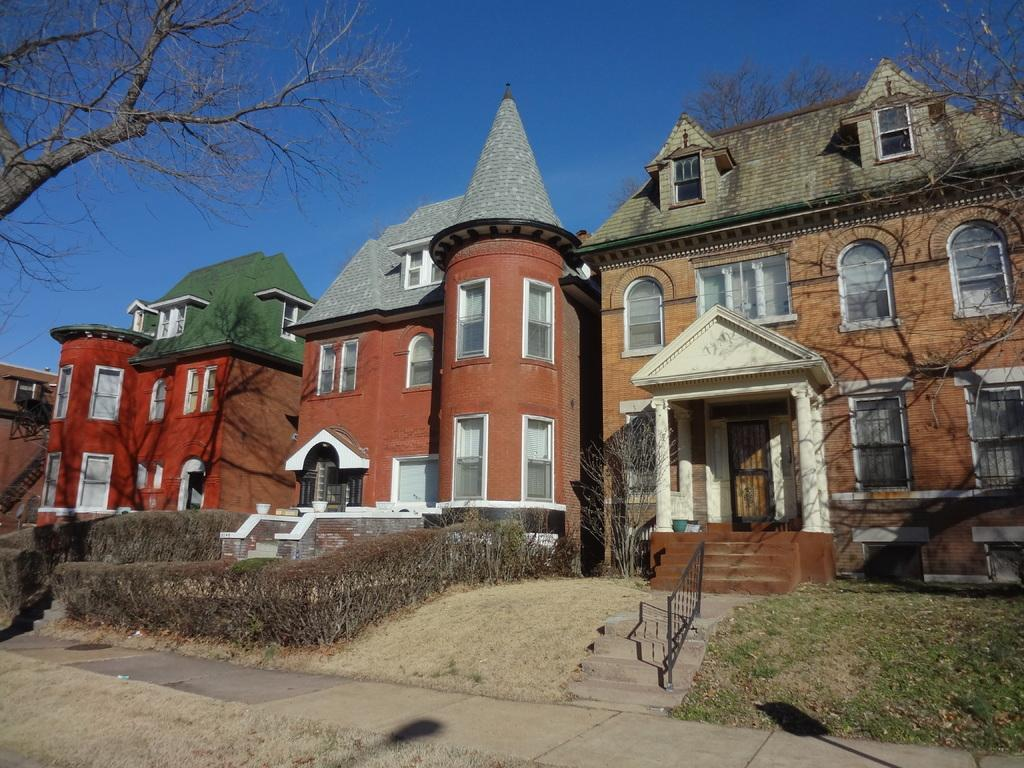What type of structures are present in the image? There are buildings in the image. What colors are the buildings? The buildings are in brown and red colors. What type of vegetation can be seen in the image? There are dried trees in the image. What is the color of the sky in the image? The sky is blue in the image. What is the organization's opinion on the rail system in the image? There is no organization or rail system present in the image, so it is not possible to determine their opinion. 